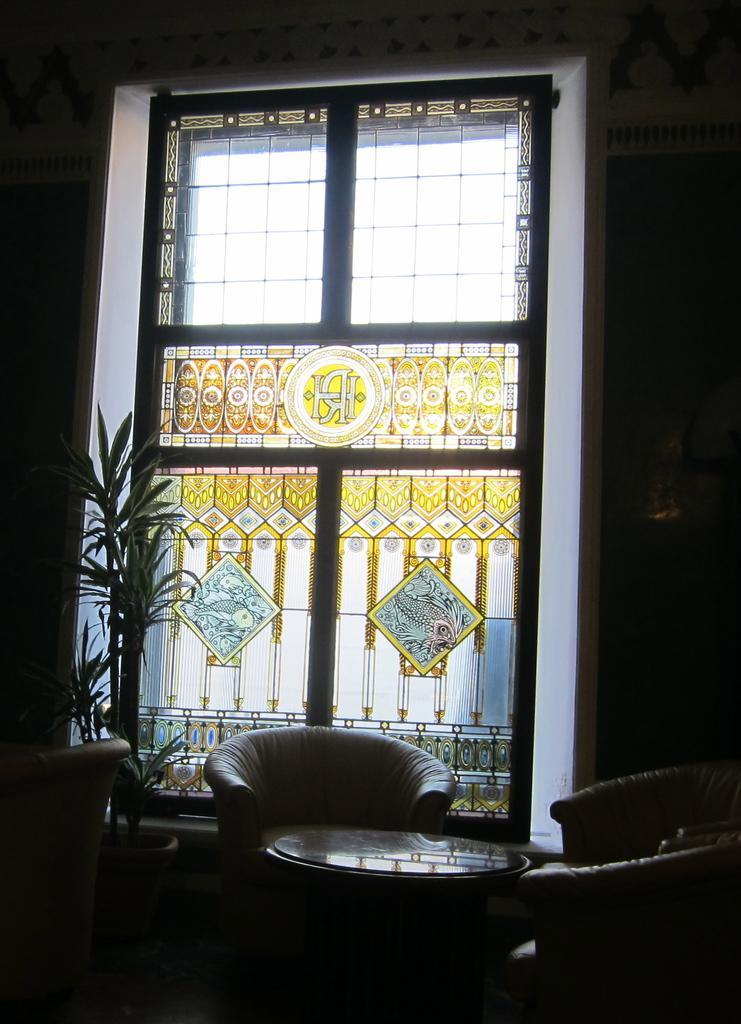Could you give a brief overview of what you see in this image? In this image i can see a window,plant and couch. 